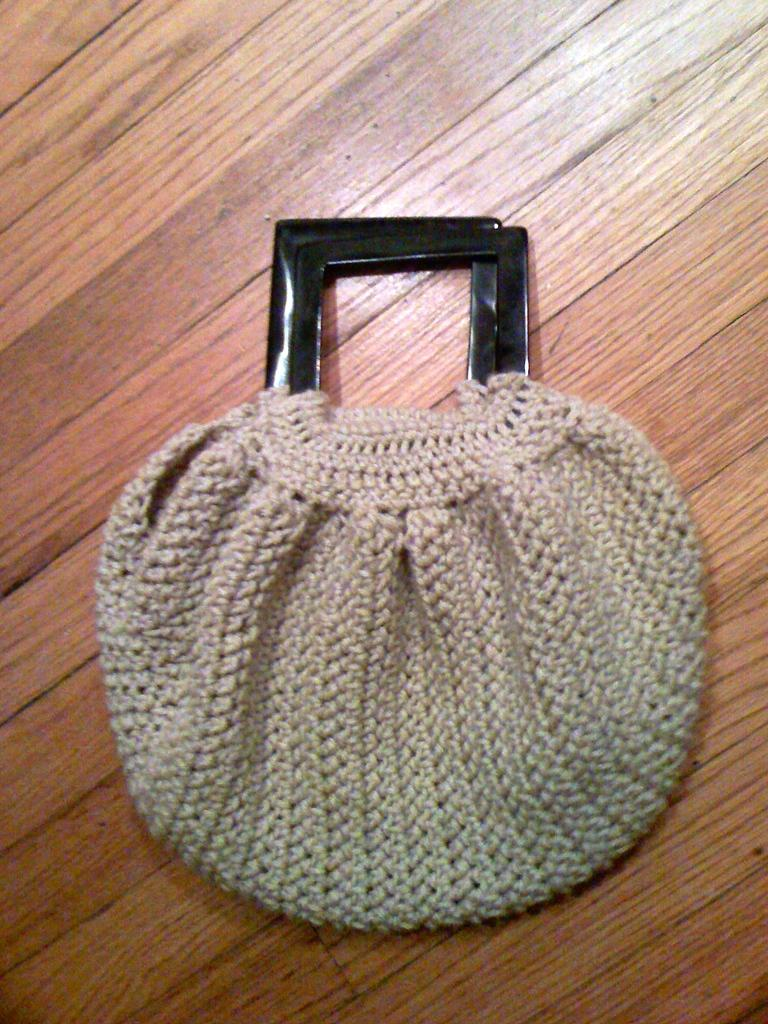What is the main object in the image? There is a handbag in the image. Can you describe the handbag in the image? The handbag appears to be a specific style or design, but the details are not clear from the image. What might the handbag be used for? The handbag is likely used for carrying personal items, such as a wallet, keys, or phone. How many robins can be seen perched on the handbag in the image? There are no robins present in the image; it only features a handbag. 